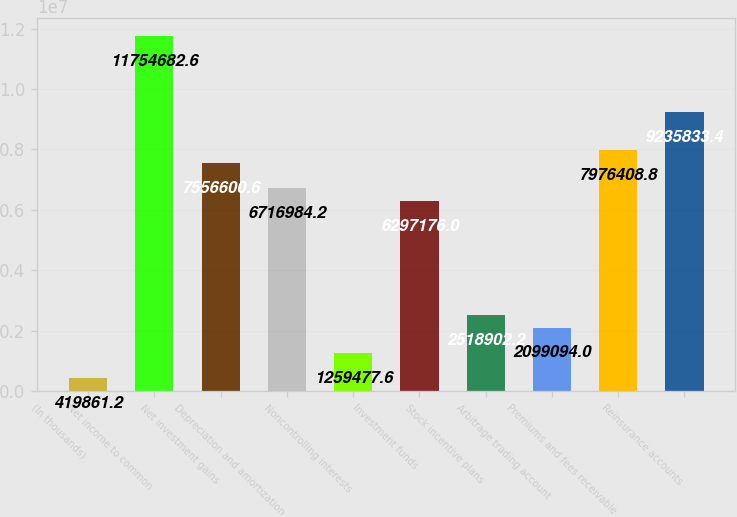<chart> <loc_0><loc_0><loc_500><loc_500><bar_chart><fcel>(In thousands)<fcel>Net income to common<fcel>Net investment gains<fcel>Depreciation and amortization<fcel>Noncontrolling interests<fcel>Investment funds<fcel>Stock incentive plans<fcel>Arbitrage trading account<fcel>Premiums and fees receivable<fcel>Reinsurance accounts<nl><fcel>419861<fcel>1.17547e+07<fcel>7.5566e+06<fcel>6.71698e+06<fcel>1.25948e+06<fcel>6.29718e+06<fcel>2.5189e+06<fcel>2.09909e+06<fcel>7.97641e+06<fcel>9.23583e+06<nl></chart> 